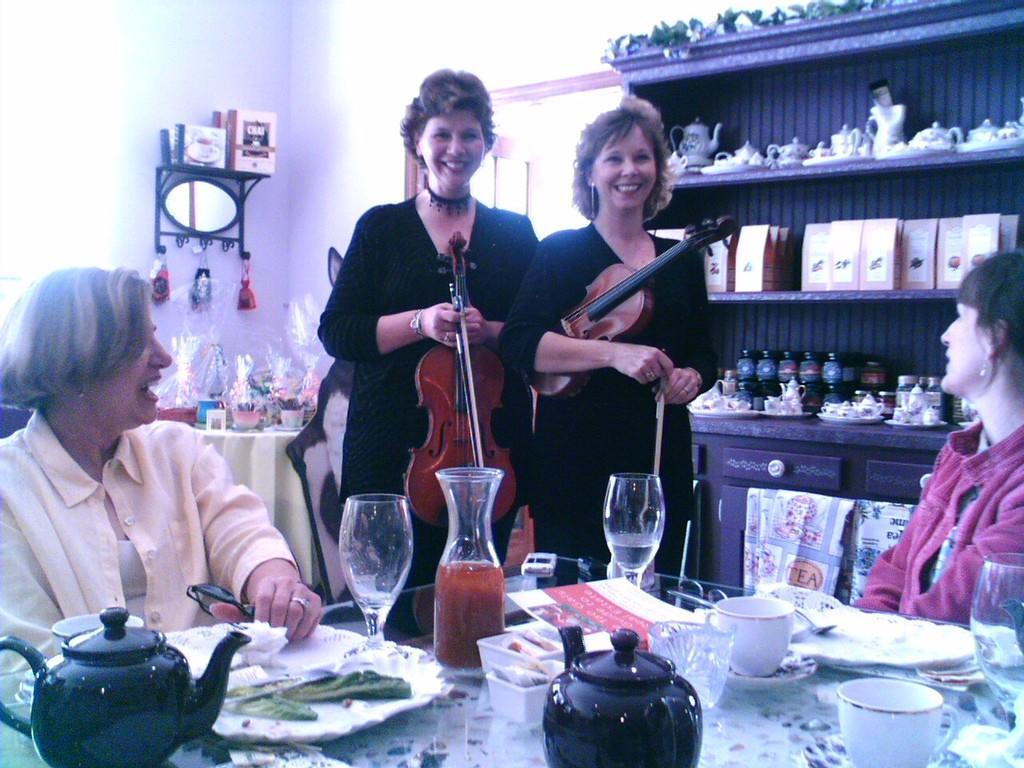Please provide a concise description of this image. In this image I can see tables, on tables I ca n see jar, cup, saucer and I can see two persons sitting on chair in front of table , two persons standing, holding violin and back side of them there is a rack, in the rack I can see bottles, cups and saucer kept in the racks and there is a mirror attached to the wall on the left side and there is a door visible on the left side 